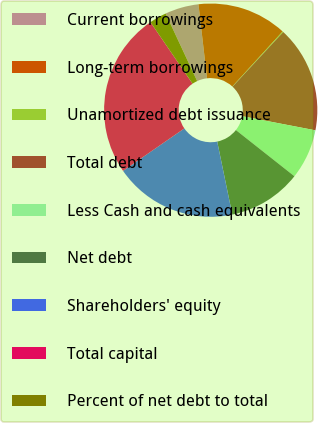Convert chart to OTSL. <chart><loc_0><loc_0><loc_500><loc_500><pie_chart><fcel>Current borrowings<fcel>Long-term borrowings<fcel>Unamortized debt issuance<fcel>Total debt<fcel>Less Cash and cash equivalents<fcel>Net debt<fcel>Shareholders' equity<fcel>Total capital<fcel>Percent of net debt to total<nl><fcel>5.11%<fcel>13.62%<fcel>0.12%<fcel>16.12%<fcel>7.61%<fcel>11.12%<fcel>18.61%<fcel>25.08%<fcel>2.61%<nl></chart> 